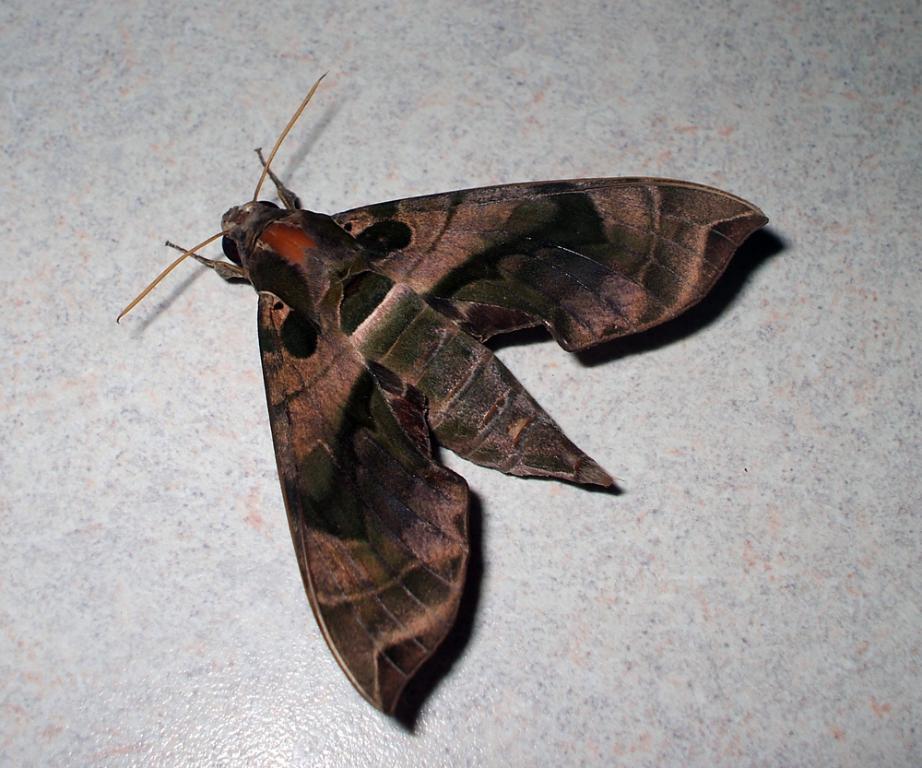Can you describe this image briefly? In this picture we can see an insect with wings sitting on the white floor. 